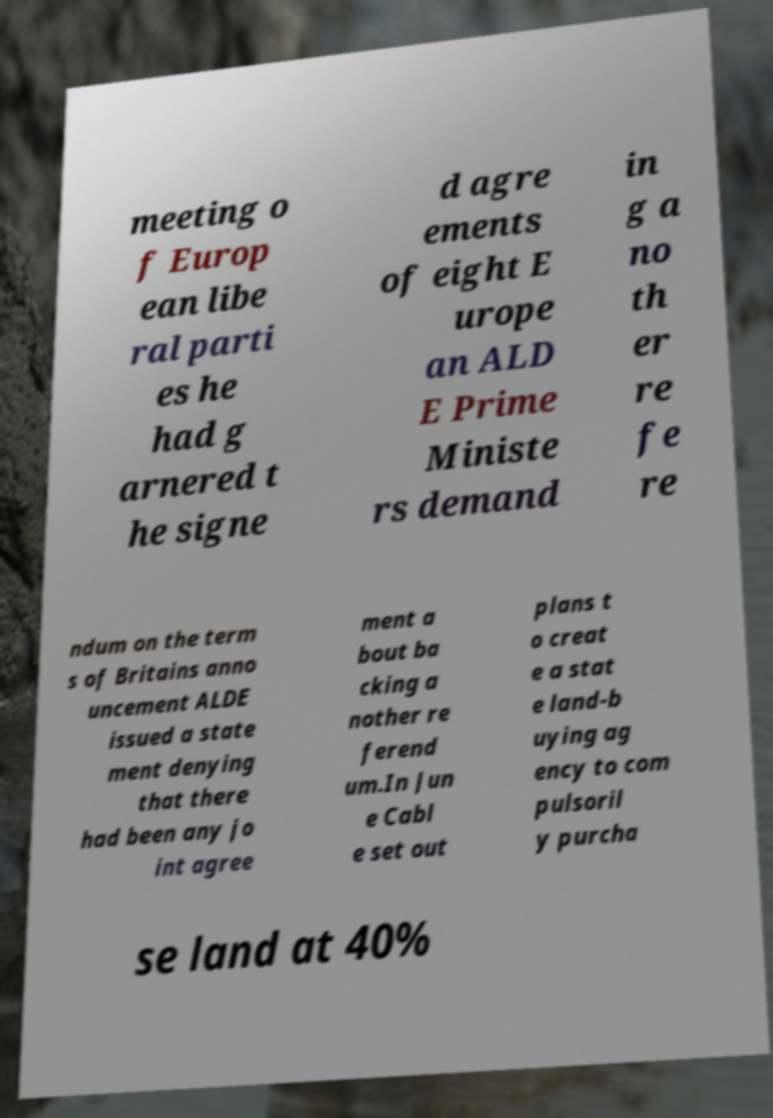Can you accurately transcribe the text from the provided image for me? meeting o f Europ ean libe ral parti es he had g arnered t he signe d agre ements of eight E urope an ALD E Prime Ministe rs demand in g a no th er re fe re ndum on the term s of Britains anno uncement ALDE issued a state ment denying that there had been any jo int agree ment a bout ba cking a nother re ferend um.In Jun e Cabl e set out plans t o creat e a stat e land-b uying ag ency to com pulsoril y purcha se land at 40% 